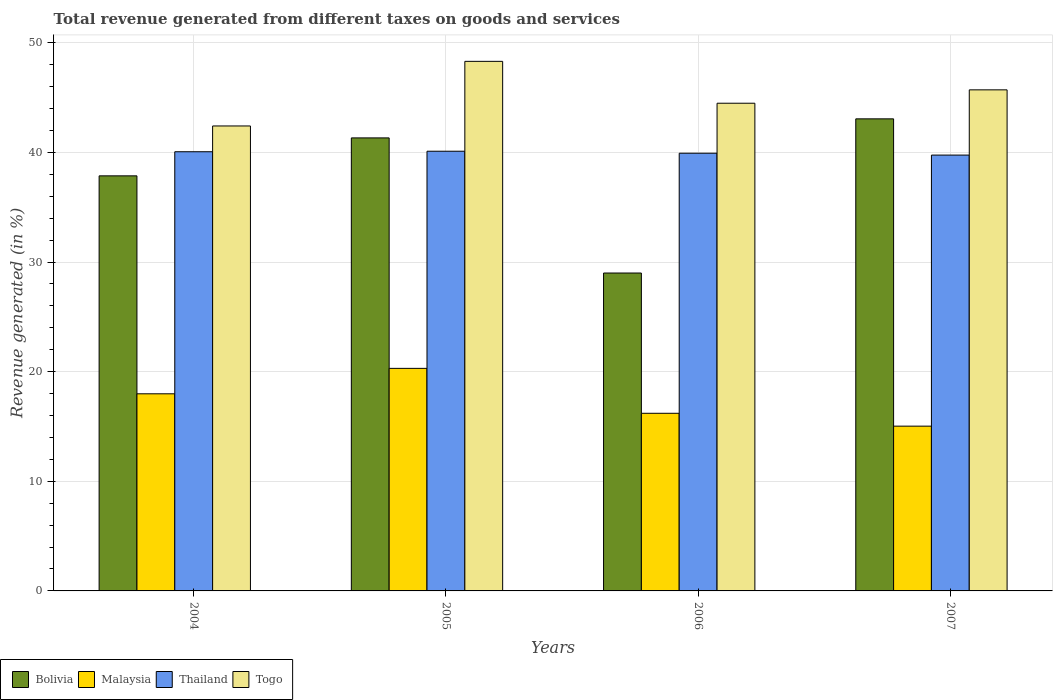How many groups of bars are there?
Give a very brief answer. 4. Are the number of bars on each tick of the X-axis equal?
Offer a terse response. Yes. What is the label of the 2nd group of bars from the left?
Offer a very short reply. 2005. What is the total revenue generated in Bolivia in 2005?
Provide a succinct answer. 41.32. Across all years, what is the maximum total revenue generated in Malaysia?
Offer a very short reply. 20.3. Across all years, what is the minimum total revenue generated in Bolivia?
Ensure brevity in your answer.  29. In which year was the total revenue generated in Thailand minimum?
Your response must be concise. 2007. What is the total total revenue generated in Togo in the graph?
Provide a succinct answer. 180.91. What is the difference between the total revenue generated in Malaysia in 2005 and that in 2006?
Offer a terse response. 4.1. What is the difference between the total revenue generated in Thailand in 2007 and the total revenue generated in Togo in 2006?
Offer a terse response. -4.73. What is the average total revenue generated in Bolivia per year?
Your response must be concise. 37.81. In the year 2004, what is the difference between the total revenue generated in Thailand and total revenue generated in Togo?
Your answer should be very brief. -2.35. What is the ratio of the total revenue generated in Togo in 2004 to that in 2007?
Give a very brief answer. 0.93. Is the difference between the total revenue generated in Thailand in 2004 and 2005 greater than the difference between the total revenue generated in Togo in 2004 and 2005?
Provide a succinct answer. Yes. What is the difference between the highest and the second highest total revenue generated in Togo?
Offer a very short reply. 2.6. What is the difference between the highest and the lowest total revenue generated in Thailand?
Ensure brevity in your answer.  0.35. In how many years, is the total revenue generated in Thailand greater than the average total revenue generated in Thailand taken over all years?
Ensure brevity in your answer.  2. Is it the case that in every year, the sum of the total revenue generated in Bolivia and total revenue generated in Togo is greater than the sum of total revenue generated in Malaysia and total revenue generated in Thailand?
Provide a short and direct response. No. What does the 4th bar from the left in 2007 represents?
Keep it short and to the point. Togo. What does the 3rd bar from the right in 2007 represents?
Ensure brevity in your answer.  Malaysia. Is it the case that in every year, the sum of the total revenue generated in Thailand and total revenue generated in Togo is greater than the total revenue generated in Malaysia?
Make the answer very short. Yes. Are all the bars in the graph horizontal?
Your answer should be very brief. No. How many years are there in the graph?
Provide a succinct answer. 4. Are the values on the major ticks of Y-axis written in scientific E-notation?
Provide a short and direct response. No. Where does the legend appear in the graph?
Provide a succinct answer. Bottom left. How are the legend labels stacked?
Offer a very short reply. Horizontal. What is the title of the graph?
Your answer should be compact. Total revenue generated from different taxes on goods and services. Does "Croatia" appear as one of the legend labels in the graph?
Offer a very short reply. No. What is the label or title of the X-axis?
Offer a terse response. Years. What is the label or title of the Y-axis?
Offer a terse response. Revenue generated (in %). What is the Revenue generated (in %) of Bolivia in 2004?
Make the answer very short. 37.86. What is the Revenue generated (in %) in Malaysia in 2004?
Provide a short and direct response. 17.98. What is the Revenue generated (in %) in Thailand in 2004?
Your answer should be compact. 40.06. What is the Revenue generated (in %) of Togo in 2004?
Offer a very short reply. 42.41. What is the Revenue generated (in %) in Bolivia in 2005?
Provide a succinct answer. 41.32. What is the Revenue generated (in %) of Malaysia in 2005?
Offer a very short reply. 20.3. What is the Revenue generated (in %) in Thailand in 2005?
Give a very brief answer. 40.11. What is the Revenue generated (in %) of Togo in 2005?
Your response must be concise. 48.31. What is the Revenue generated (in %) in Bolivia in 2006?
Your answer should be compact. 29. What is the Revenue generated (in %) of Malaysia in 2006?
Your answer should be very brief. 16.2. What is the Revenue generated (in %) in Thailand in 2006?
Offer a terse response. 39.93. What is the Revenue generated (in %) of Togo in 2006?
Offer a terse response. 44.49. What is the Revenue generated (in %) of Bolivia in 2007?
Offer a terse response. 43.06. What is the Revenue generated (in %) of Malaysia in 2007?
Provide a succinct answer. 15.03. What is the Revenue generated (in %) in Thailand in 2007?
Make the answer very short. 39.76. What is the Revenue generated (in %) in Togo in 2007?
Provide a succinct answer. 45.71. Across all years, what is the maximum Revenue generated (in %) of Bolivia?
Your answer should be compact. 43.06. Across all years, what is the maximum Revenue generated (in %) of Malaysia?
Provide a succinct answer. 20.3. Across all years, what is the maximum Revenue generated (in %) of Thailand?
Keep it short and to the point. 40.11. Across all years, what is the maximum Revenue generated (in %) of Togo?
Provide a succinct answer. 48.31. Across all years, what is the minimum Revenue generated (in %) of Bolivia?
Your answer should be compact. 29. Across all years, what is the minimum Revenue generated (in %) of Malaysia?
Your answer should be compact. 15.03. Across all years, what is the minimum Revenue generated (in %) in Thailand?
Provide a succinct answer. 39.76. Across all years, what is the minimum Revenue generated (in %) in Togo?
Provide a short and direct response. 42.41. What is the total Revenue generated (in %) in Bolivia in the graph?
Your answer should be very brief. 151.25. What is the total Revenue generated (in %) in Malaysia in the graph?
Provide a short and direct response. 69.52. What is the total Revenue generated (in %) in Thailand in the graph?
Your answer should be compact. 159.85. What is the total Revenue generated (in %) in Togo in the graph?
Your answer should be compact. 180.91. What is the difference between the Revenue generated (in %) of Bolivia in 2004 and that in 2005?
Keep it short and to the point. -3.46. What is the difference between the Revenue generated (in %) in Malaysia in 2004 and that in 2005?
Provide a short and direct response. -2.32. What is the difference between the Revenue generated (in %) of Thailand in 2004 and that in 2005?
Keep it short and to the point. -0.05. What is the difference between the Revenue generated (in %) in Togo in 2004 and that in 2005?
Your response must be concise. -5.89. What is the difference between the Revenue generated (in %) in Bolivia in 2004 and that in 2006?
Keep it short and to the point. 8.86. What is the difference between the Revenue generated (in %) of Malaysia in 2004 and that in 2006?
Give a very brief answer. 1.78. What is the difference between the Revenue generated (in %) of Thailand in 2004 and that in 2006?
Offer a very short reply. 0.13. What is the difference between the Revenue generated (in %) of Togo in 2004 and that in 2006?
Make the answer very short. -2.07. What is the difference between the Revenue generated (in %) in Bolivia in 2004 and that in 2007?
Provide a succinct answer. -5.2. What is the difference between the Revenue generated (in %) in Malaysia in 2004 and that in 2007?
Provide a short and direct response. 2.95. What is the difference between the Revenue generated (in %) of Thailand in 2004 and that in 2007?
Provide a succinct answer. 0.3. What is the difference between the Revenue generated (in %) in Togo in 2004 and that in 2007?
Ensure brevity in your answer.  -3.29. What is the difference between the Revenue generated (in %) in Bolivia in 2005 and that in 2006?
Your response must be concise. 12.32. What is the difference between the Revenue generated (in %) of Malaysia in 2005 and that in 2006?
Make the answer very short. 4.1. What is the difference between the Revenue generated (in %) in Thailand in 2005 and that in 2006?
Give a very brief answer. 0.18. What is the difference between the Revenue generated (in %) in Togo in 2005 and that in 2006?
Your answer should be very brief. 3.82. What is the difference between the Revenue generated (in %) in Bolivia in 2005 and that in 2007?
Provide a succinct answer. -1.74. What is the difference between the Revenue generated (in %) in Malaysia in 2005 and that in 2007?
Your response must be concise. 5.27. What is the difference between the Revenue generated (in %) of Thailand in 2005 and that in 2007?
Ensure brevity in your answer.  0.35. What is the difference between the Revenue generated (in %) in Togo in 2005 and that in 2007?
Your response must be concise. 2.6. What is the difference between the Revenue generated (in %) in Bolivia in 2006 and that in 2007?
Provide a short and direct response. -14.06. What is the difference between the Revenue generated (in %) of Malaysia in 2006 and that in 2007?
Offer a terse response. 1.17. What is the difference between the Revenue generated (in %) of Thailand in 2006 and that in 2007?
Provide a succinct answer. 0.17. What is the difference between the Revenue generated (in %) of Togo in 2006 and that in 2007?
Your answer should be very brief. -1.22. What is the difference between the Revenue generated (in %) of Bolivia in 2004 and the Revenue generated (in %) of Malaysia in 2005?
Your answer should be very brief. 17.56. What is the difference between the Revenue generated (in %) in Bolivia in 2004 and the Revenue generated (in %) in Thailand in 2005?
Keep it short and to the point. -2.25. What is the difference between the Revenue generated (in %) in Bolivia in 2004 and the Revenue generated (in %) in Togo in 2005?
Keep it short and to the point. -10.44. What is the difference between the Revenue generated (in %) in Malaysia in 2004 and the Revenue generated (in %) in Thailand in 2005?
Give a very brief answer. -22.13. What is the difference between the Revenue generated (in %) in Malaysia in 2004 and the Revenue generated (in %) in Togo in 2005?
Provide a succinct answer. -30.33. What is the difference between the Revenue generated (in %) of Thailand in 2004 and the Revenue generated (in %) of Togo in 2005?
Give a very brief answer. -8.25. What is the difference between the Revenue generated (in %) of Bolivia in 2004 and the Revenue generated (in %) of Malaysia in 2006?
Your response must be concise. 21.66. What is the difference between the Revenue generated (in %) of Bolivia in 2004 and the Revenue generated (in %) of Thailand in 2006?
Keep it short and to the point. -2.06. What is the difference between the Revenue generated (in %) of Bolivia in 2004 and the Revenue generated (in %) of Togo in 2006?
Provide a succinct answer. -6.62. What is the difference between the Revenue generated (in %) in Malaysia in 2004 and the Revenue generated (in %) in Thailand in 2006?
Make the answer very short. -21.95. What is the difference between the Revenue generated (in %) of Malaysia in 2004 and the Revenue generated (in %) of Togo in 2006?
Give a very brief answer. -26.5. What is the difference between the Revenue generated (in %) of Thailand in 2004 and the Revenue generated (in %) of Togo in 2006?
Your answer should be compact. -4.43. What is the difference between the Revenue generated (in %) in Bolivia in 2004 and the Revenue generated (in %) in Malaysia in 2007?
Offer a terse response. 22.83. What is the difference between the Revenue generated (in %) in Bolivia in 2004 and the Revenue generated (in %) in Thailand in 2007?
Your answer should be very brief. -1.89. What is the difference between the Revenue generated (in %) in Bolivia in 2004 and the Revenue generated (in %) in Togo in 2007?
Provide a short and direct response. -7.84. What is the difference between the Revenue generated (in %) of Malaysia in 2004 and the Revenue generated (in %) of Thailand in 2007?
Offer a terse response. -21.77. What is the difference between the Revenue generated (in %) of Malaysia in 2004 and the Revenue generated (in %) of Togo in 2007?
Provide a short and direct response. -27.73. What is the difference between the Revenue generated (in %) in Thailand in 2004 and the Revenue generated (in %) in Togo in 2007?
Provide a short and direct response. -5.65. What is the difference between the Revenue generated (in %) of Bolivia in 2005 and the Revenue generated (in %) of Malaysia in 2006?
Your response must be concise. 25.12. What is the difference between the Revenue generated (in %) in Bolivia in 2005 and the Revenue generated (in %) in Thailand in 2006?
Give a very brief answer. 1.4. What is the difference between the Revenue generated (in %) of Bolivia in 2005 and the Revenue generated (in %) of Togo in 2006?
Your response must be concise. -3.16. What is the difference between the Revenue generated (in %) in Malaysia in 2005 and the Revenue generated (in %) in Thailand in 2006?
Ensure brevity in your answer.  -19.63. What is the difference between the Revenue generated (in %) in Malaysia in 2005 and the Revenue generated (in %) in Togo in 2006?
Your answer should be very brief. -24.19. What is the difference between the Revenue generated (in %) in Thailand in 2005 and the Revenue generated (in %) in Togo in 2006?
Offer a very short reply. -4.38. What is the difference between the Revenue generated (in %) in Bolivia in 2005 and the Revenue generated (in %) in Malaysia in 2007?
Provide a short and direct response. 26.29. What is the difference between the Revenue generated (in %) of Bolivia in 2005 and the Revenue generated (in %) of Thailand in 2007?
Your answer should be very brief. 1.57. What is the difference between the Revenue generated (in %) in Bolivia in 2005 and the Revenue generated (in %) in Togo in 2007?
Provide a short and direct response. -4.38. What is the difference between the Revenue generated (in %) of Malaysia in 2005 and the Revenue generated (in %) of Thailand in 2007?
Your answer should be compact. -19.46. What is the difference between the Revenue generated (in %) in Malaysia in 2005 and the Revenue generated (in %) in Togo in 2007?
Offer a terse response. -25.41. What is the difference between the Revenue generated (in %) of Thailand in 2005 and the Revenue generated (in %) of Togo in 2007?
Keep it short and to the point. -5.6. What is the difference between the Revenue generated (in %) in Bolivia in 2006 and the Revenue generated (in %) in Malaysia in 2007?
Keep it short and to the point. 13.97. What is the difference between the Revenue generated (in %) in Bolivia in 2006 and the Revenue generated (in %) in Thailand in 2007?
Keep it short and to the point. -10.76. What is the difference between the Revenue generated (in %) in Bolivia in 2006 and the Revenue generated (in %) in Togo in 2007?
Offer a very short reply. -16.71. What is the difference between the Revenue generated (in %) in Malaysia in 2006 and the Revenue generated (in %) in Thailand in 2007?
Offer a very short reply. -23.55. What is the difference between the Revenue generated (in %) of Malaysia in 2006 and the Revenue generated (in %) of Togo in 2007?
Make the answer very short. -29.5. What is the difference between the Revenue generated (in %) in Thailand in 2006 and the Revenue generated (in %) in Togo in 2007?
Keep it short and to the point. -5.78. What is the average Revenue generated (in %) of Bolivia per year?
Keep it short and to the point. 37.81. What is the average Revenue generated (in %) in Malaysia per year?
Your response must be concise. 17.38. What is the average Revenue generated (in %) of Thailand per year?
Keep it short and to the point. 39.96. What is the average Revenue generated (in %) of Togo per year?
Ensure brevity in your answer.  45.23. In the year 2004, what is the difference between the Revenue generated (in %) of Bolivia and Revenue generated (in %) of Malaysia?
Make the answer very short. 19.88. In the year 2004, what is the difference between the Revenue generated (in %) in Bolivia and Revenue generated (in %) in Thailand?
Make the answer very short. -2.2. In the year 2004, what is the difference between the Revenue generated (in %) in Bolivia and Revenue generated (in %) in Togo?
Provide a succinct answer. -4.55. In the year 2004, what is the difference between the Revenue generated (in %) of Malaysia and Revenue generated (in %) of Thailand?
Provide a succinct answer. -22.08. In the year 2004, what is the difference between the Revenue generated (in %) in Malaysia and Revenue generated (in %) in Togo?
Ensure brevity in your answer.  -24.43. In the year 2004, what is the difference between the Revenue generated (in %) of Thailand and Revenue generated (in %) of Togo?
Your answer should be very brief. -2.35. In the year 2005, what is the difference between the Revenue generated (in %) in Bolivia and Revenue generated (in %) in Malaysia?
Your response must be concise. 21.02. In the year 2005, what is the difference between the Revenue generated (in %) in Bolivia and Revenue generated (in %) in Thailand?
Ensure brevity in your answer.  1.21. In the year 2005, what is the difference between the Revenue generated (in %) of Bolivia and Revenue generated (in %) of Togo?
Your response must be concise. -6.98. In the year 2005, what is the difference between the Revenue generated (in %) in Malaysia and Revenue generated (in %) in Thailand?
Keep it short and to the point. -19.81. In the year 2005, what is the difference between the Revenue generated (in %) of Malaysia and Revenue generated (in %) of Togo?
Your answer should be compact. -28.01. In the year 2005, what is the difference between the Revenue generated (in %) in Thailand and Revenue generated (in %) in Togo?
Offer a terse response. -8.2. In the year 2006, what is the difference between the Revenue generated (in %) in Bolivia and Revenue generated (in %) in Malaysia?
Offer a terse response. 12.8. In the year 2006, what is the difference between the Revenue generated (in %) in Bolivia and Revenue generated (in %) in Thailand?
Keep it short and to the point. -10.93. In the year 2006, what is the difference between the Revenue generated (in %) in Bolivia and Revenue generated (in %) in Togo?
Offer a terse response. -15.49. In the year 2006, what is the difference between the Revenue generated (in %) in Malaysia and Revenue generated (in %) in Thailand?
Offer a very short reply. -23.72. In the year 2006, what is the difference between the Revenue generated (in %) of Malaysia and Revenue generated (in %) of Togo?
Your answer should be very brief. -28.28. In the year 2006, what is the difference between the Revenue generated (in %) in Thailand and Revenue generated (in %) in Togo?
Ensure brevity in your answer.  -4.56. In the year 2007, what is the difference between the Revenue generated (in %) of Bolivia and Revenue generated (in %) of Malaysia?
Provide a succinct answer. 28.03. In the year 2007, what is the difference between the Revenue generated (in %) in Bolivia and Revenue generated (in %) in Thailand?
Keep it short and to the point. 3.31. In the year 2007, what is the difference between the Revenue generated (in %) of Bolivia and Revenue generated (in %) of Togo?
Provide a short and direct response. -2.65. In the year 2007, what is the difference between the Revenue generated (in %) in Malaysia and Revenue generated (in %) in Thailand?
Offer a very short reply. -24.73. In the year 2007, what is the difference between the Revenue generated (in %) of Malaysia and Revenue generated (in %) of Togo?
Make the answer very short. -30.68. In the year 2007, what is the difference between the Revenue generated (in %) in Thailand and Revenue generated (in %) in Togo?
Your response must be concise. -5.95. What is the ratio of the Revenue generated (in %) of Bolivia in 2004 to that in 2005?
Your response must be concise. 0.92. What is the ratio of the Revenue generated (in %) of Malaysia in 2004 to that in 2005?
Offer a terse response. 0.89. What is the ratio of the Revenue generated (in %) in Thailand in 2004 to that in 2005?
Give a very brief answer. 1. What is the ratio of the Revenue generated (in %) in Togo in 2004 to that in 2005?
Offer a terse response. 0.88. What is the ratio of the Revenue generated (in %) in Bolivia in 2004 to that in 2006?
Give a very brief answer. 1.31. What is the ratio of the Revenue generated (in %) in Malaysia in 2004 to that in 2006?
Your answer should be compact. 1.11. What is the ratio of the Revenue generated (in %) of Togo in 2004 to that in 2006?
Your answer should be very brief. 0.95. What is the ratio of the Revenue generated (in %) of Bolivia in 2004 to that in 2007?
Your response must be concise. 0.88. What is the ratio of the Revenue generated (in %) of Malaysia in 2004 to that in 2007?
Your response must be concise. 1.2. What is the ratio of the Revenue generated (in %) in Thailand in 2004 to that in 2007?
Your answer should be very brief. 1.01. What is the ratio of the Revenue generated (in %) of Togo in 2004 to that in 2007?
Give a very brief answer. 0.93. What is the ratio of the Revenue generated (in %) in Bolivia in 2005 to that in 2006?
Keep it short and to the point. 1.43. What is the ratio of the Revenue generated (in %) in Malaysia in 2005 to that in 2006?
Give a very brief answer. 1.25. What is the ratio of the Revenue generated (in %) of Thailand in 2005 to that in 2006?
Offer a very short reply. 1. What is the ratio of the Revenue generated (in %) of Togo in 2005 to that in 2006?
Offer a very short reply. 1.09. What is the ratio of the Revenue generated (in %) in Bolivia in 2005 to that in 2007?
Your answer should be compact. 0.96. What is the ratio of the Revenue generated (in %) in Malaysia in 2005 to that in 2007?
Keep it short and to the point. 1.35. What is the ratio of the Revenue generated (in %) of Thailand in 2005 to that in 2007?
Provide a short and direct response. 1.01. What is the ratio of the Revenue generated (in %) of Togo in 2005 to that in 2007?
Your response must be concise. 1.06. What is the ratio of the Revenue generated (in %) of Bolivia in 2006 to that in 2007?
Offer a terse response. 0.67. What is the ratio of the Revenue generated (in %) in Malaysia in 2006 to that in 2007?
Offer a very short reply. 1.08. What is the ratio of the Revenue generated (in %) of Thailand in 2006 to that in 2007?
Offer a terse response. 1. What is the ratio of the Revenue generated (in %) of Togo in 2006 to that in 2007?
Your response must be concise. 0.97. What is the difference between the highest and the second highest Revenue generated (in %) in Bolivia?
Ensure brevity in your answer.  1.74. What is the difference between the highest and the second highest Revenue generated (in %) in Malaysia?
Your answer should be very brief. 2.32. What is the difference between the highest and the second highest Revenue generated (in %) of Thailand?
Offer a terse response. 0.05. What is the difference between the highest and the second highest Revenue generated (in %) of Togo?
Offer a very short reply. 2.6. What is the difference between the highest and the lowest Revenue generated (in %) in Bolivia?
Keep it short and to the point. 14.06. What is the difference between the highest and the lowest Revenue generated (in %) in Malaysia?
Keep it short and to the point. 5.27. What is the difference between the highest and the lowest Revenue generated (in %) in Thailand?
Offer a terse response. 0.35. What is the difference between the highest and the lowest Revenue generated (in %) of Togo?
Provide a short and direct response. 5.89. 